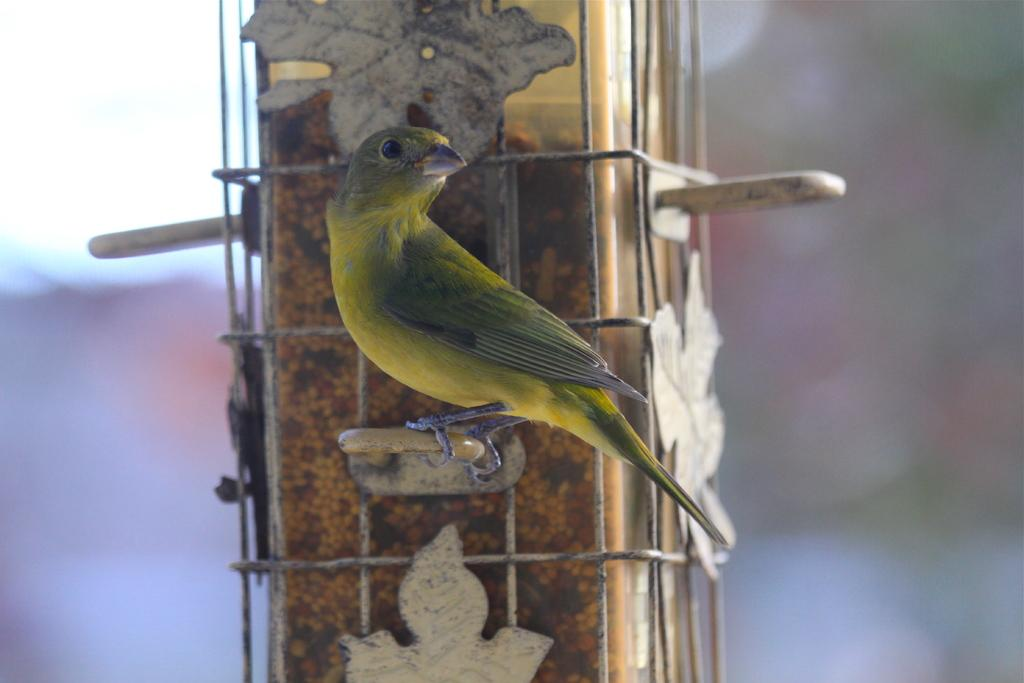What type of bird is in the image? There is a bunting bird in the image. What is the bird standing on? The bird is standing on a stick. What other structure can be seen in the image? There is a pillar in the image. What part of the sky is visible in the image? The sky is visible in the top left corner of the image. How many crates are stacked next to the bird in the image? There are no crates present in the image. What type of dinosaur can be seen in the image? There are no dinosaurs present in the image. 